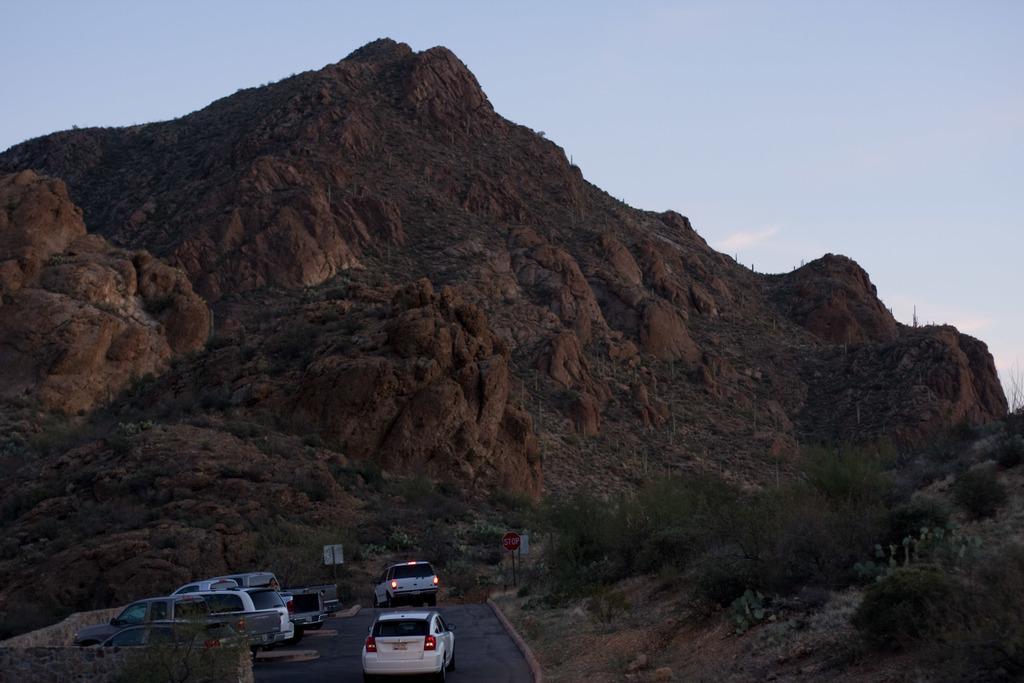Describe this image in one or two sentences. In this image we can see vehicles on the road. There are plants, poles, boards, wall, and mountain. In the background there is sky. 